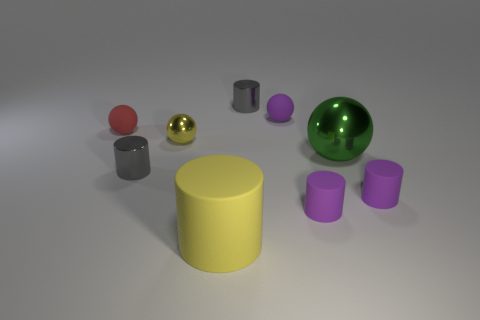What is the texture of the surface the objects are resting upon? The surface appears to be smooth and even, with a slight matte finish, which diffuses the light softly. It looks to be a non-reflective material, possibly a type of plastic or coated surface. 